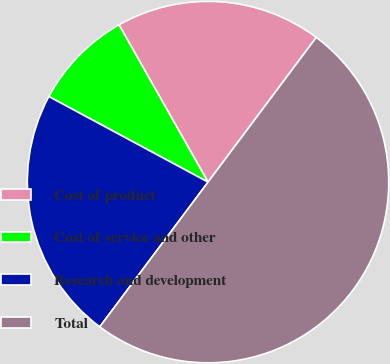Convert chart to OTSL. <chart><loc_0><loc_0><loc_500><loc_500><pie_chart><fcel>Cost of product<fcel>Cost of service and other<fcel>Research and development<fcel>Total<nl><fcel>18.42%<fcel>8.95%<fcel>22.63%<fcel>50.0%<nl></chart> 